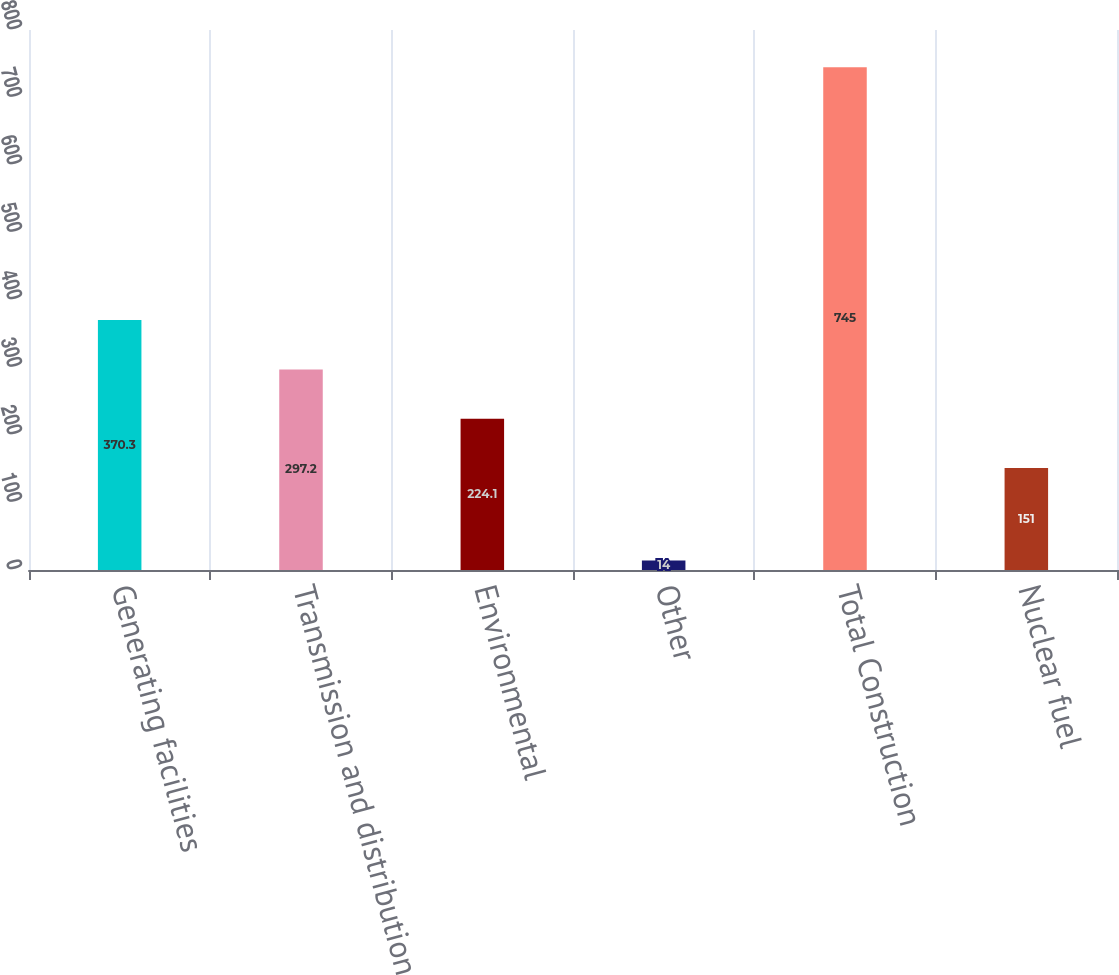Convert chart. <chart><loc_0><loc_0><loc_500><loc_500><bar_chart><fcel>Generating facilities<fcel>Transmission and distribution<fcel>Environmental<fcel>Other<fcel>Total Construction<fcel>Nuclear fuel<nl><fcel>370.3<fcel>297.2<fcel>224.1<fcel>14<fcel>745<fcel>151<nl></chart> 